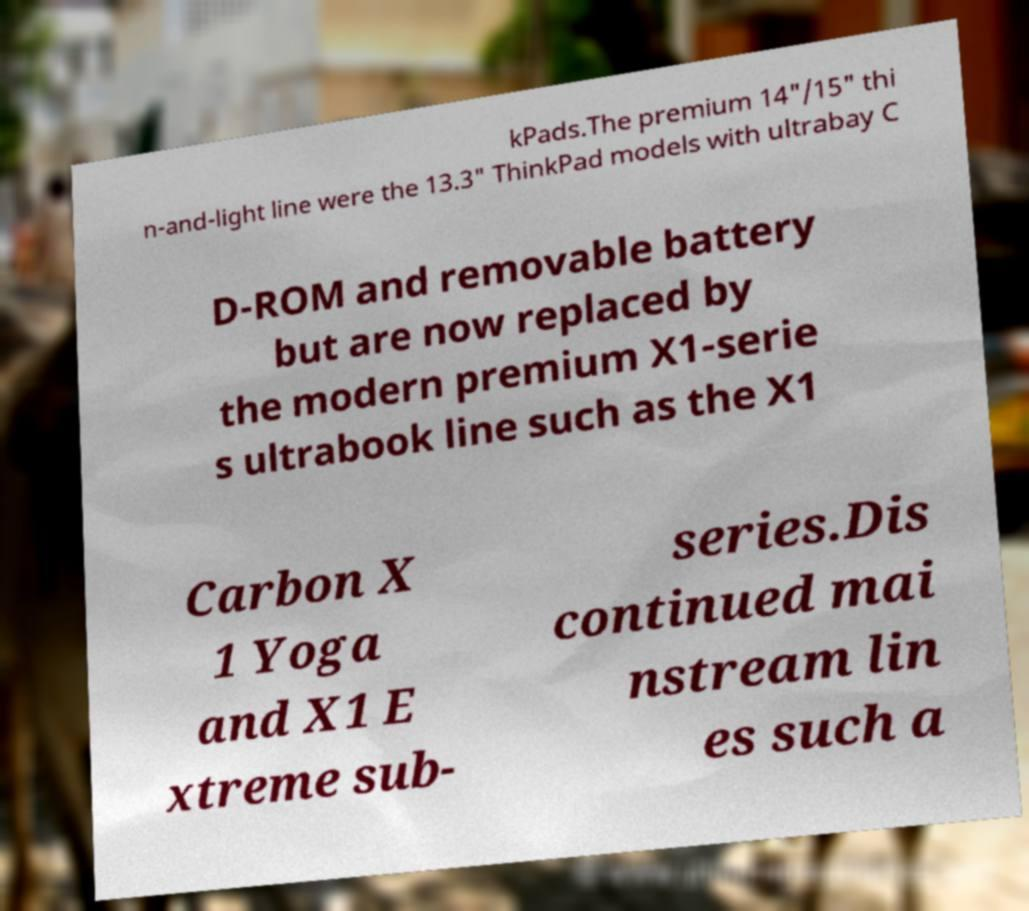Can you accurately transcribe the text from the provided image for me? kPads.The premium 14"/15" thi n-and-light line were the 13.3" ThinkPad models with ultrabay C D-ROM and removable battery but are now replaced by the modern premium X1-serie s ultrabook line such as the X1 Carbon X 1 Yoga and X1 E xtreme sub- series.Dis continued mai nstream lin es such a 